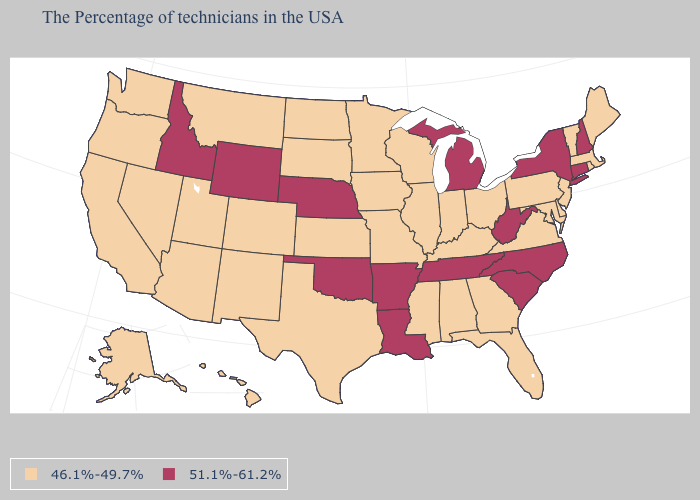Which states have the lowest value in the USA?
Give a very brief answer. Maine, Massachusetts, Rhode Island, Vermont, New Jersey, Delaware, Maryland, Pennsylvania, Virginia, Ohio, Florida, Georgia, Kentucky, Indiana, Alabama, Wisconsin, Illinois, Mississippi, Missouri, Minnesota, Iowa, Kansas, Texas, South Dakota, North Dakota, Colorado, New Mexico, Utah, Montana, Arizona, Nevada, California, Washington, Oregon, Alaska, Hawaii. What is the lowest value in the West?
Give a very brief answer. 46.1%-49.7%. What is the highest value in the MidWest ?
Write a very short answer. 51.1%-61.2%. What is the value of West Virginia?
Quick response, please. 51.1%-61.2%. Which states have the lowest value in the USA?
Short answer required. Maine, Massachusetts, Rhode Island, Vermont, New Jersey, Delaware, Maryland, Pennsylvania, Virginia, Ohio, Florida, Georgia, Kentucky, Indiana, Alabama, Wisconsin, Illinois, Mississippi, Missouri, Minnesota, Iowa, Kansas, Texas, South Dakota, North Dakota, Colorado, New Mexico, Utah, Montana, Arizona, Nevada, California, Washington, Oregon, Alaska, Hawaii. What is the value of Connecticut?
Concise answer only. 51.1%-61.2%. Which states hav the highest value in the South?
Short answer required. North Carolina, South Carolina, West Virginia, Tennessee, Louisiana, Arkansas, Oklahoma. Among the states that border Nebraska , does Missouri have the highest value?
Give a very brief answer. No. What is the highest value in states that border Kentucky?
Give a very brief answer. 51.1%-61.2%. Name the states that have a value in the range 46.1%-49.7%?
Give a very brief answer. Maine, Massachusetts, Rhode Island, Vermont, New Jersey, Delaware, Maryland, Pennsylvania, Virginia, Ohio, Florida, Georgia, Kentucky, Indiana, Alabama, Wisconsin, Illinois, Mississippi, Missouri, Minnesota, Iowa, Kansas, Texas, South Dakota, North Dakota, Colorado, New Mexico, Utah, Montana, Arizona, Nevada, California, Washington, Oregon, Alaska, Hawaii. What is the lowest value in states that border Georgia?
Quick response, please. 46.1%-49.7%. What is the value of Oklahoma?
Short answer required. 51.1%-61.2%. What is the highest value in the USA?
Write a very short answer. 51.1%-61.2%. 